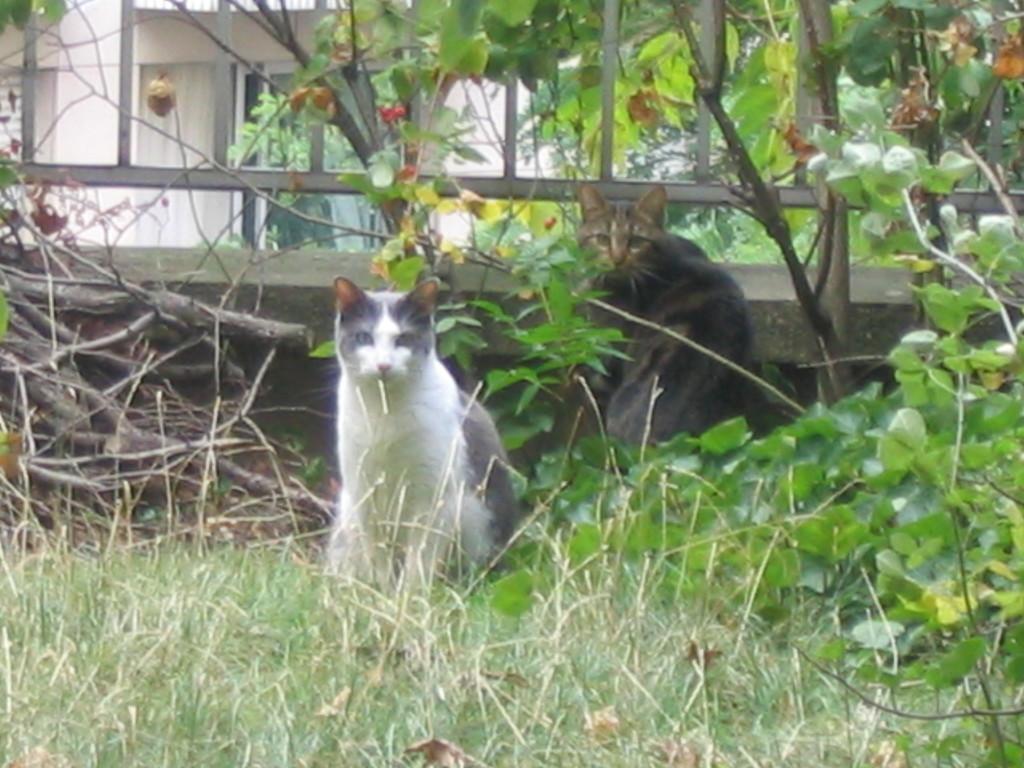How would you summarize this image in a sentence or two? In this image there is grass at the bottom. There are animals in the foreground. There are dry branches and stems on the left corner. There are plants on the right corner. There is a metal fence, there is a building, there are trees in the background. 